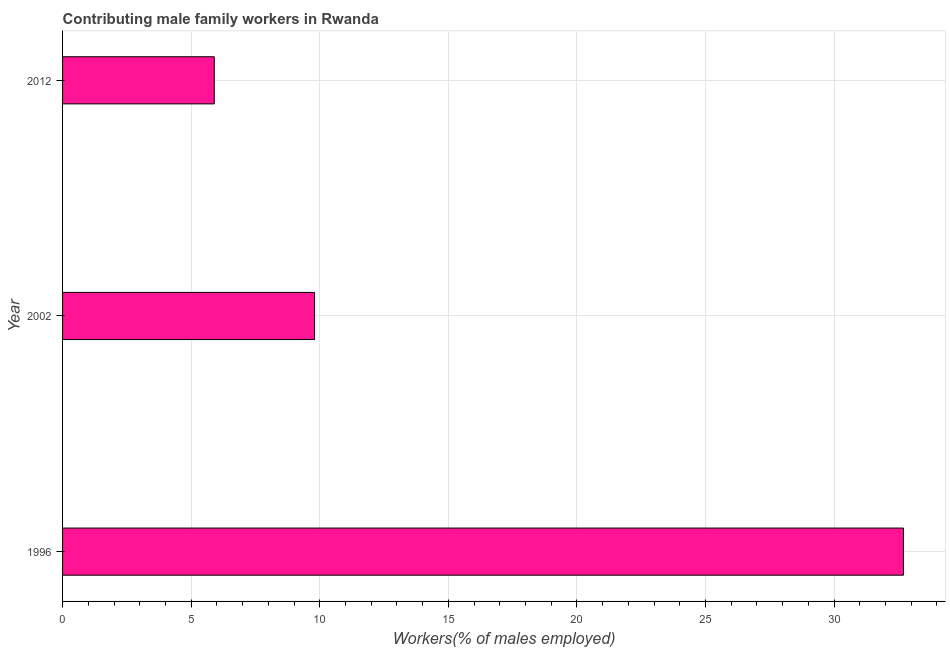What is the title of the graph?
Keep it short and to the point. Contributing male family workers in Rwanda. What is the label or title of the X-axis?
Your answer should be very brief. Workers(% of males employed). What is the contributing male family workers in 2012?
Your answer should be compact. 5.9. Across all years, what is the maximum contributing male family workers?
Make the answer very short. 32.7. Across all years, what is the minimum contributing male family workers?
Give a very brief answer. 5.9. In which year was the contributing male family workers maximum?
Make the answer very short. 1996. In which year was the contributing male family workers minimum?
Give a very brief answer. 2012. What is the sum of the contributing male family workers?
Offer a terse response. 48.4. What is the difference between the contributing male family workers in 1996 and 2002?
Your response must be concise. 22.9. What is the average contributing male family workers per year?
Make the answer very short. 16.13. What is the median contributing male family workers?
Provide a short and direct response. 9.8. What is the ratio of the contributing male family workers in 1996 to that in 2002?
Give a very brief answer. 3.34. What is the difference between the highest and the second highest contributing male family workers?
Offer a terse response. 22.9. What is the difference between the highest and the lowest contributing male family workers?
Ensure brevity in your answer.  26.8. How many bars are there?
Your response must be concise. 3. Are all the bars in the graph horizontal?
Your answer should be compact. Yes. Are the values on the major ticks of X-axis written in scientific E-notation?
Offer a very short reply. No. What is the Workers(% of males employed) of 1996?
Ensure brevity in your answer.  32.7. What is the Workers(% of males employed) of 2002?
Your answer should be very brief. 9.8. What is the Workers(% of males employed) in 2012?
Offer a very short reply. 5.9. What is the difference between the Workers(% of males employed) in 1996 and 2002?
Offer a terse response. 22.9. What is the difference between the Workers(% of males employed) in 1996 and 2012?
Your response must be concise. 26.8. What is the ratio of the Workers(% of males employed) in 1996 to that in 2002?
Make the answer very short. 3.34. What is the ratio of the Workers(% of males employed) in 1996 to that in 2012?
Offer a very short reply. 5.54. What is the ratio of the Workers(% of males employed) in 2002 to that in 2012?
Make the answer very short. 1.66. 